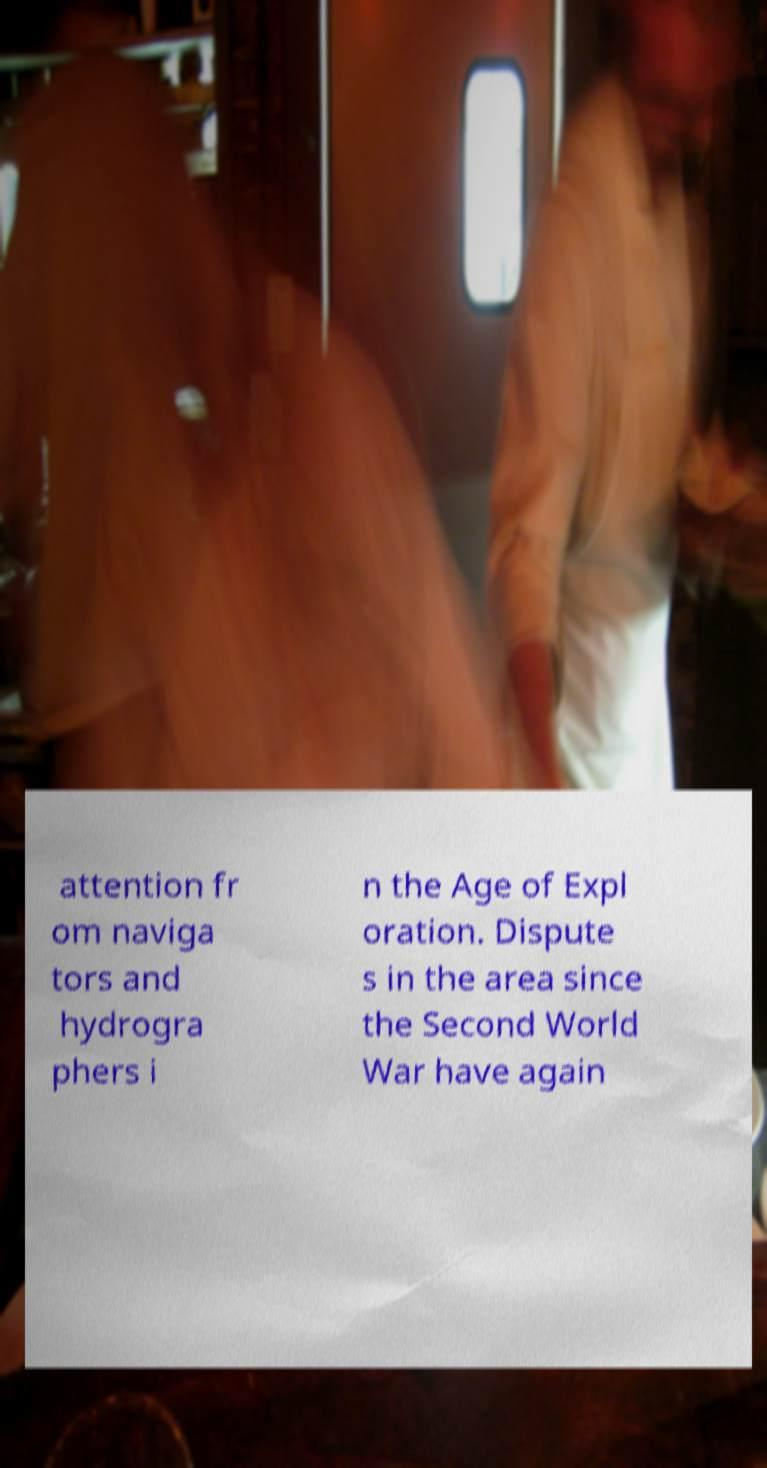Can you read and provide the text displayed in the image?This photo seems to have some interesting text. Can you extract and type it out for me? attention fr om naviga tors and hydrogra phers i n the Age of Expl oration. Dispute s in the area since the Second World War have again 